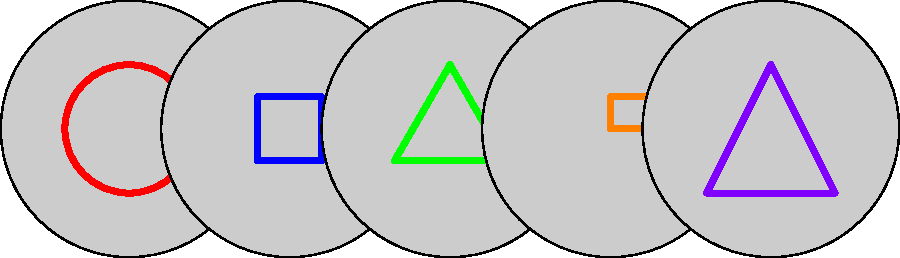Complete the sequence by identifying the next sprite in this iconic 8-bit and 16-bit era game pattern. To solve this sequence completion problem, let's analyze the pattern of sprites:

1. The first sprite is a red circle, reminiscent of Pac-Man.
2. The second sprite is a blue square, similar to the ghosts in Pac-Man.
3. The third sprite is a green triangle, which could represent a ship from Asteroids.
4. The fourth sprite is an orange rectangle, possibly symbolizing a paddle from Breakout or Pong.
5. The fifth sprite is a purple diamond shape, resembling a crystal or gem from various platformers.

The pattern seems to be progressing through different iconic shapes from classic video games. To complete the sequence, we need to think of another iconic shape that fits this retro game theme.

Considering the simplicity of these shapes and their connection to early video games, the most logical next step would be a simple shape that represents another classic game element.

One of the most iconic and simple shapes from early video games that hasn't been used yet is the invader from Space Invaders. These were typically represented by simple pixelated shapes, often resembling a basic alien form with "arms" extending from a blocky body.

Therefore, the next sprite in the sequence should be a shape reminiscent of a Space Invader alien, completing this nostalgic journey through classic video game iconography.
Answer: Space Invader alien shape 